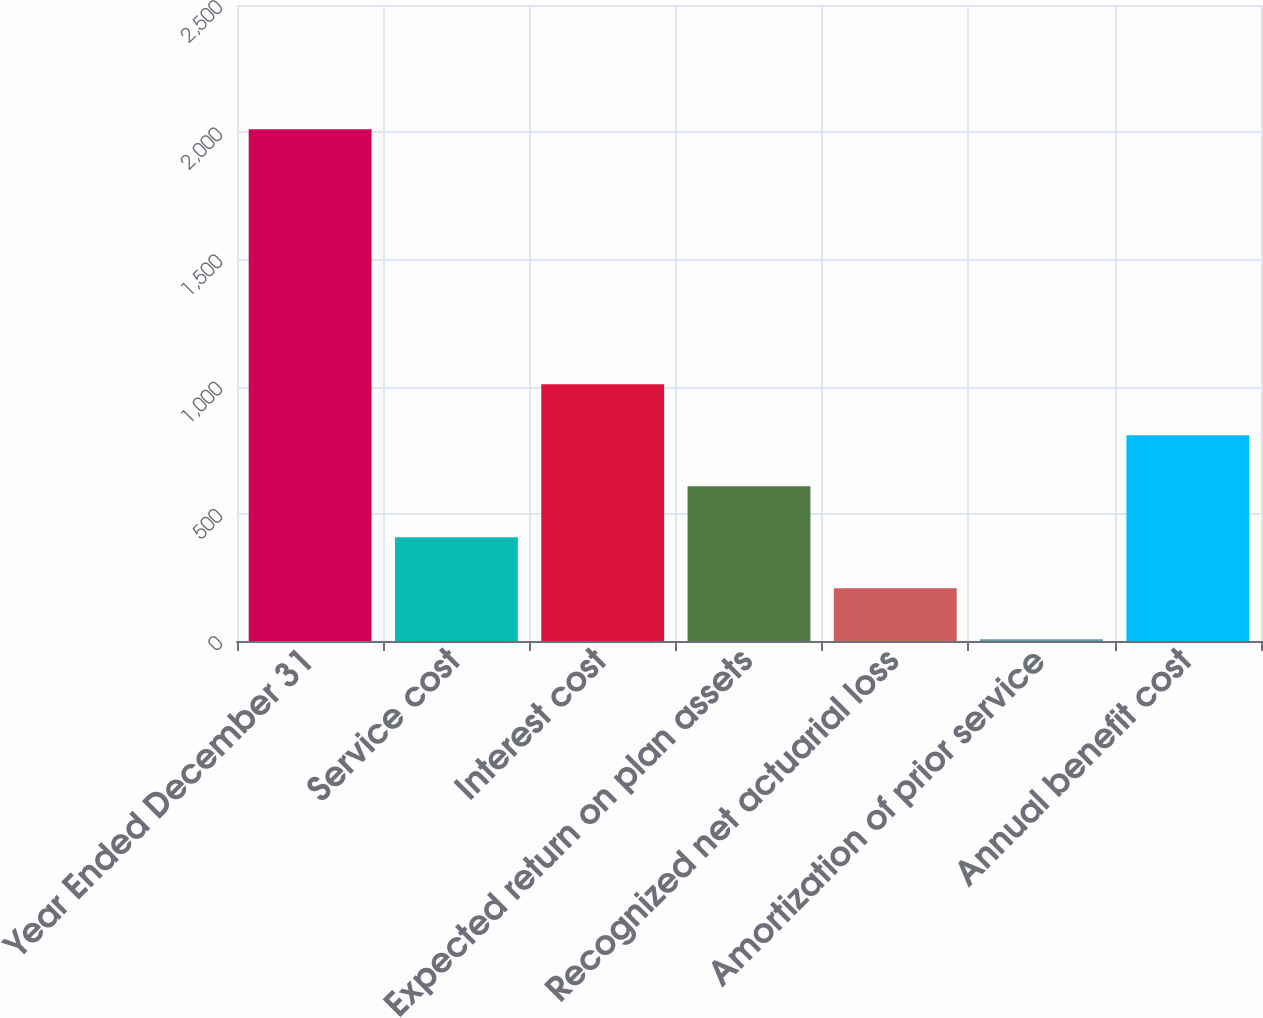Convert chart. <chart><loc_0><loc_0><loc_500><loc_500><bar_chart><fcel>Year Ended December 31<fcel>Service cost<fcel>Interest cost<fcel>Expected return on plan assets<fcel>Recognized net actuarial loss<fcel>Amortization of prior service<fcel>Annual benefit cost<nl><fcel>2012<fcel>408<fcel>1009.5<fcel>608.5<fcel>207.5<fcel>7<fcel>809<nl></chart> 